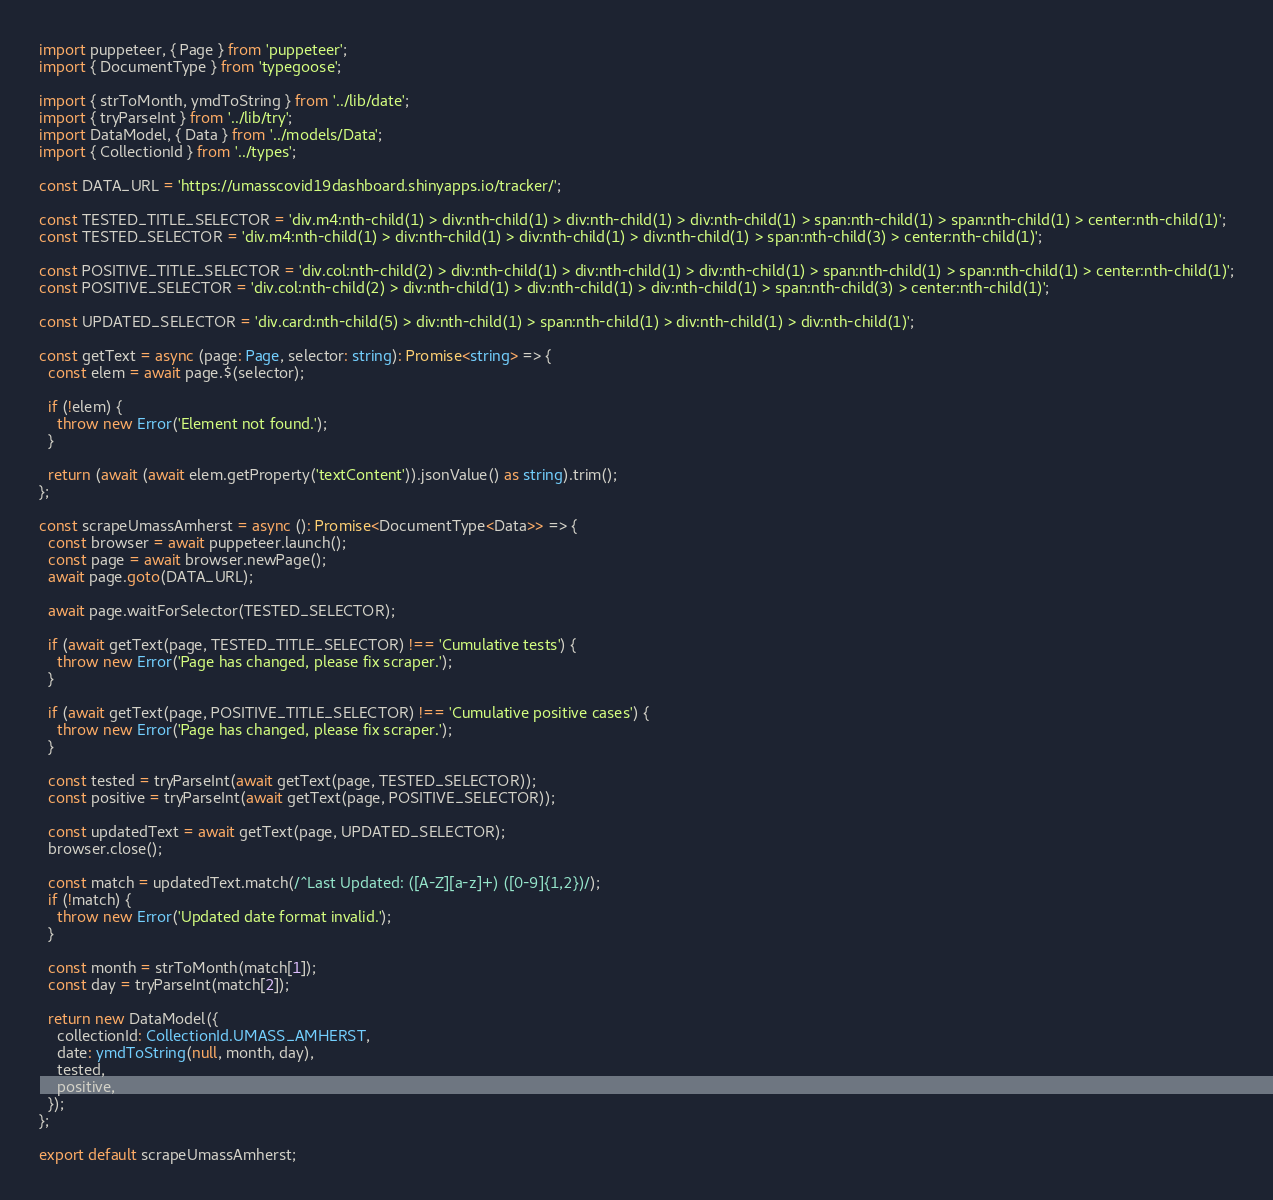Convert code to text. <code><loc_0><loc_0><loc_500><loc_500><_TypeScript_>import puppeteer, { Page } from 'puppeteer';
import { DocumentType } from 'typegoose';

import { strToMonth, ymdToString } from '../lib/date';
import { tryParseInt } from '../lib/try';
import DataModel, { Data } from '../models/Data';
import { CollectionId } from '../types';

const DATA_URL = 'https://umasscovid19dashboard.shinyapps.io/tracker/';

const TESTED_TITLE_SELECTOR = 'div.m4:nth-child(1) > div:nth-child(1) > div:nth-child(1) > div:nth-child(1) > span:nth-child(1) > span:nth-child(1) > center:nth-child(1)';
const TESTED_SELECTOR = 'div.m4:nth-child(1) > div:nth-child(1) > div:nth-child(1) > div:nth-child(1) > span:nth-child(3) > center:nth-child(1)';

const POSITIVE_TITLE_SELECTOR = 'div.col:nth-child(2) > div:nth-child(1) > div:nth-child(1) > div:nth-child(1) > span:nth-child(1) > span:nth-child(1) > center:nth-child(1)';
const POSITIVE_SELECTOR = 'div.col:nth-child(2) > div:nth-child(1) > div:nth-child(1) > div:nth-child(1) > span:nth-child(3) > center:nth-child(1)';

const UPDATED_SELECTOR = 'div.card:nth-child(5) > div:nth-child(1) > span:nth-child(1) > div:nth-child(1) > div:nth-child(1)';

const getText = async (page: Page, selector: string): Promise<string> => {
  const elem = await page.$(selector);

  if (!elem) {
    throw new Error('Element not found.');
  }

  return (await (await elem.getProperty('textContent')).jsonValue() as string).trim();
};

const scrapeUmassAmherst = async (): Promise<DocumentType<Data>> => {
  const browser = await puppeteer.launch();
  const page = await browser.newPage();
  await page.goto(DATA_URL);

  await page.waitForSelector(TESTED_SELECTOR);

  if (await getText(page, TESTED_TITLE_SELECTOR) !== 'Cumulative tests') {
    throw new Error('Page has changed, please fix scraper.');
  }

  if (await getText(page, POSITIVE_TITLE_SELECTOR) !== 'Cumulative positive cases') {
    throw new Error('Page has changed, please fix scraper.');
  }

  const tested = tryParseInt(await getText(page, TESTED_SELECTOR));
  const positive = tryParseInt(await getText(page, POSITIVE_SELECTOR));

  const updatedText = await getText(page, UPDATED_SELECTOR);
  browser.close();

  const match = updatedText.match(/^Last Updated: ([A-Z][a-z]+) ([0-9]{1,2})/);
  if (!match) {
    throw new Error('Updated date format invalid.');
  }

  const month = strToMonth(match[1]);
  const day = tryParseInt(match[2]);

  return new DataModel({
    collectionId: CollectionId.UMASS_AMHERST,
    date: ymdToString(null, month, day),
    tested,
    positive,
  });
};

export default scrapeUmassAmherst;
</code> 